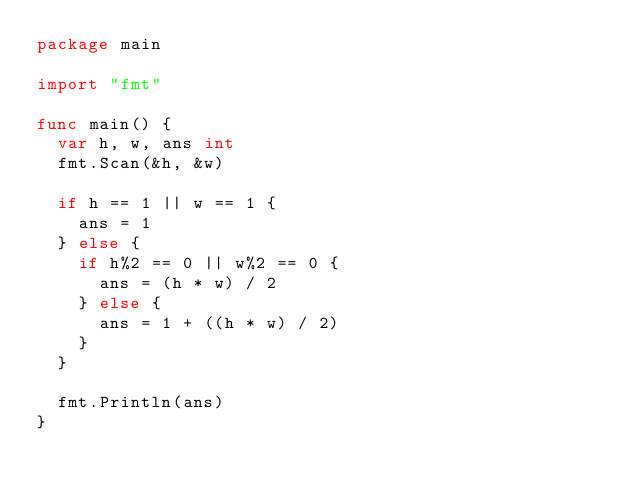<code> <loc_0><loc_0><loc_500><loc_500><_Go_>package main

import "fmt"

func main() {
	var h, w, ans int
	fmt.Scan(&h, &w)

	if h == 1 || w == 1 {
		ans = 1
	} else {
		if h%2 == 0 || w%2 == 0 {
			ans = (h * w) / 2
		} else {
			ans = 1 + ((h * w) / 2)
		}
	}

	fmt.Println(ans)
}</code> 